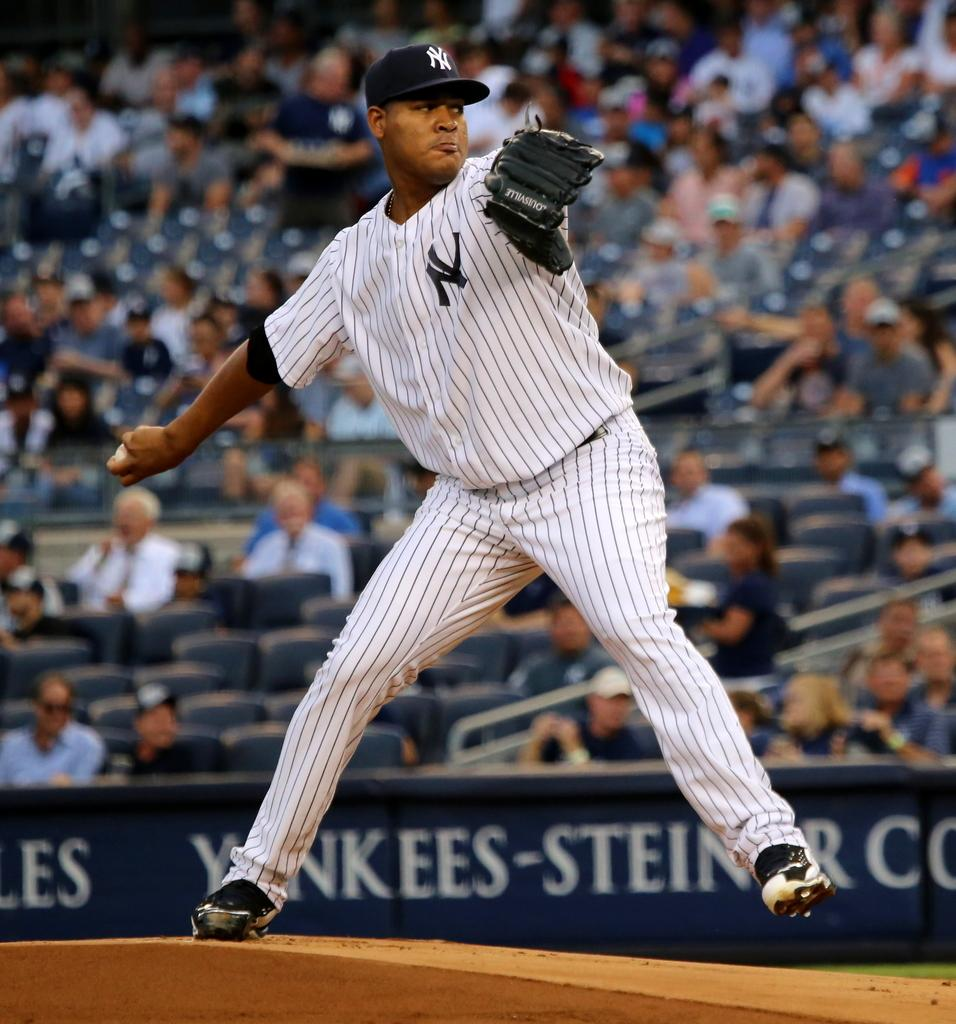<image>
Give a short and clear explanation of the subsequent image. A player with a Yankees hat and an ad behind them that says Yankees Steiner 